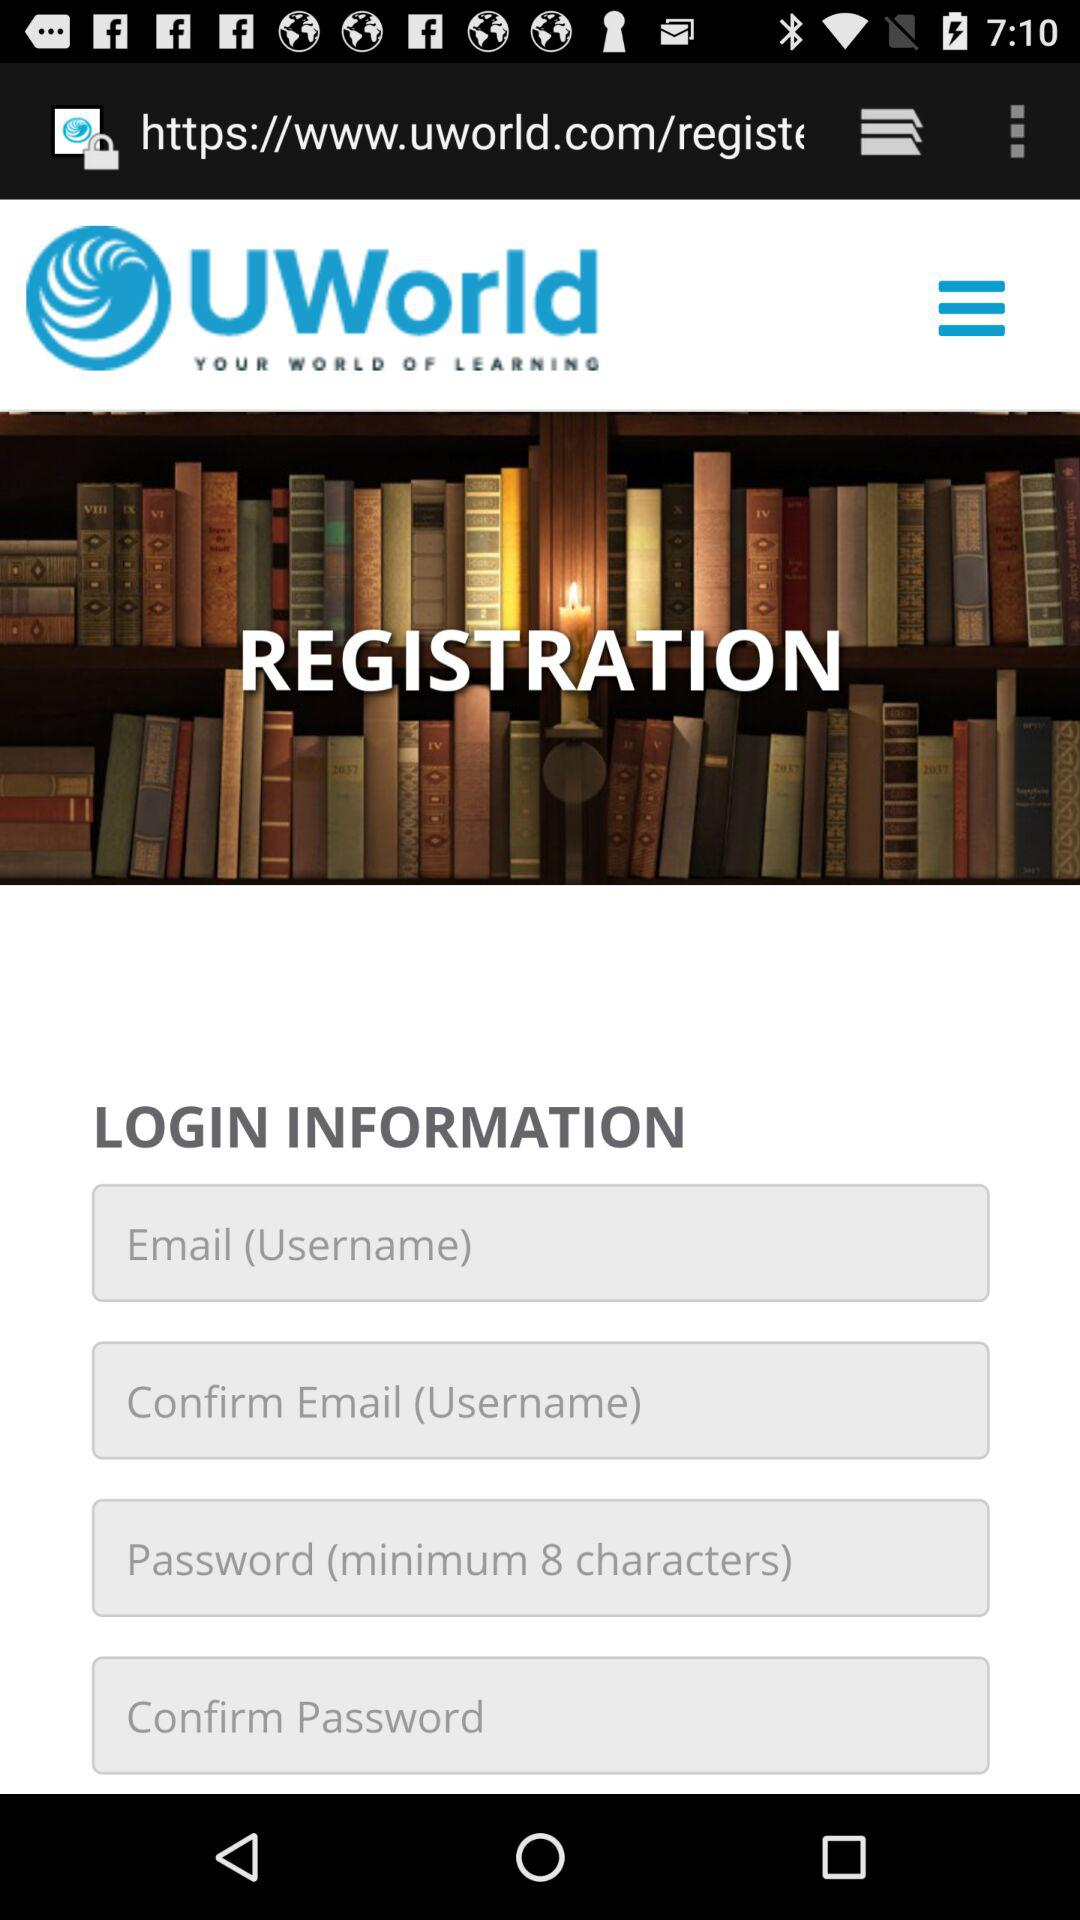How many input fields are there for the login information?
Answer the question using a single word or phrase. 4 